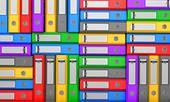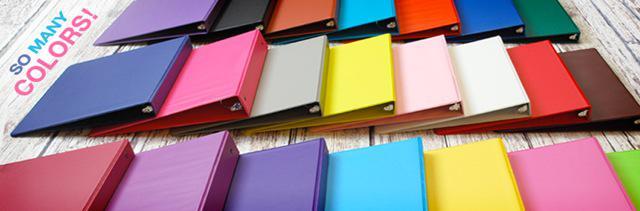The first image is the image on the left, the second image is the image on the right. Evaluate the accuracy of this statement regarding the images: "There are shelves in the image on the right". Is it true? Answer yes or no. No. The first image is the image on the left, the second image is the image on the right. For the images shown, is this caption "At least one image shows a single row of colored binders with white rectangular labels." true? Answer yes or no. No. 